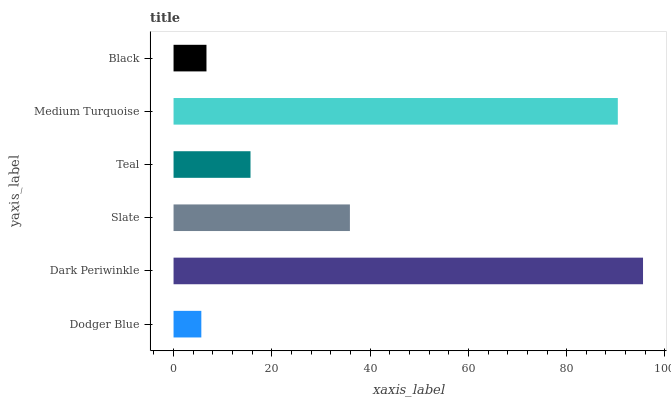Is Dodger Blue the minimum?
Answer yes or no. Yes. Is Dark Periwinkle the maximum?
Answer yes or no. Yes. Is Slate the minimum?
Answer yes or no. No. Is Slate the maximum?
Answer yes or no. No. Is Dark Periwinkle greater than Slate?
Answer yes or no. Yes. Is Slate less than Dark Periwinkle?
Answer yes or no. Yes. Is Slate greater than Dark Periwinkle?
Answer yes or no. No. Is Dark Periwinkle less than Slate?
Answer yes or no. No. Is Slate the high median?
Answer yes or no. Yes. Is Teal the low median?
Answer yes or no. Yes. Is Teal the high median?
Answer yes or no. No. Is Black the low median?
Answer yes or no. No. 